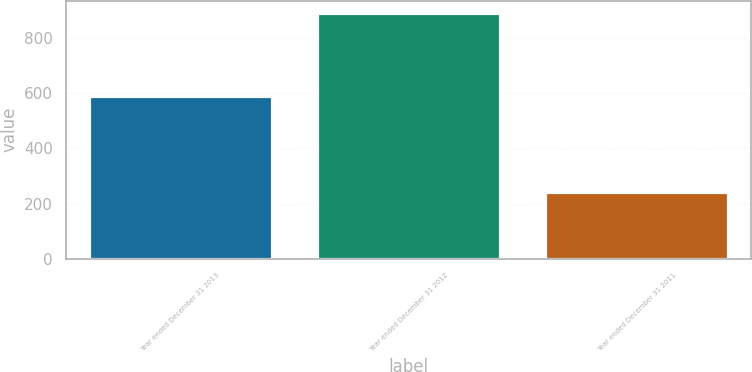Convert chart. <chart><loc_0><loc_0><loc_500><loc_500><bar_chart><fcel>Year ended December 31 2013<fcel>Year ended December 31 2012<fcel>Year ended December 31 2011<nl><fcel>589<fcel>891<fcel>242<nl></chart> 